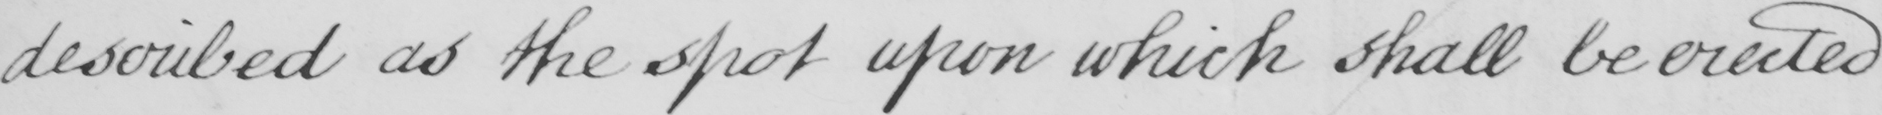What text is written in this handwritten line? described as the spot upon which shall be erected 